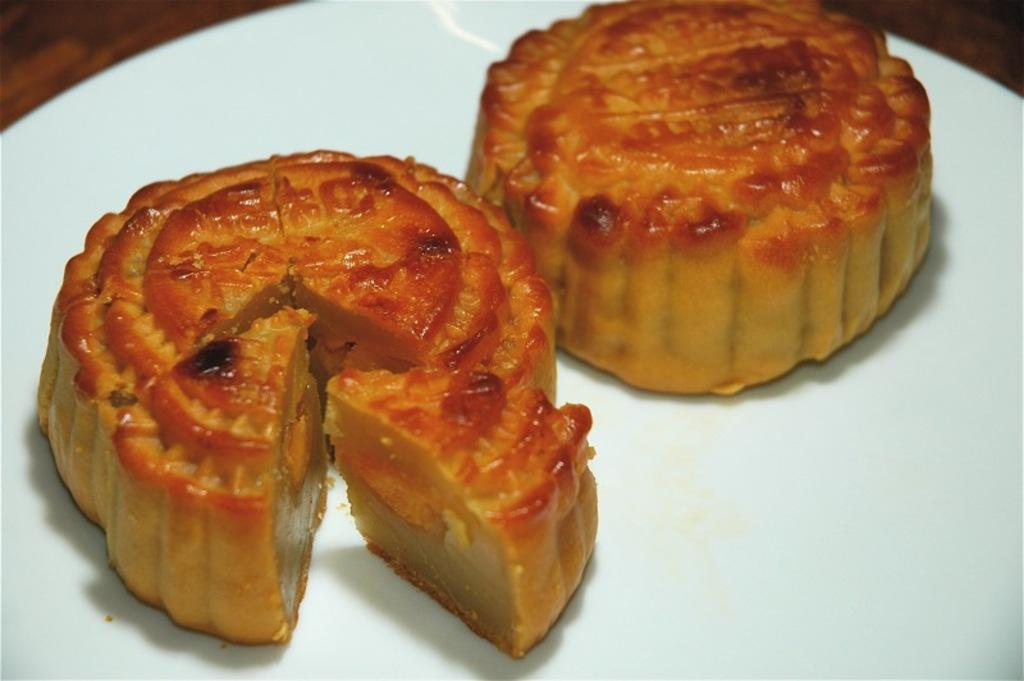What is on the plate in the image? There is food on the plate in the image. What type of surface is the plate placed on? The wooden platform is present in the image. What activity is the chicken performing in the image? There is no chicken present in the image, so it is not possible to answer that question. 